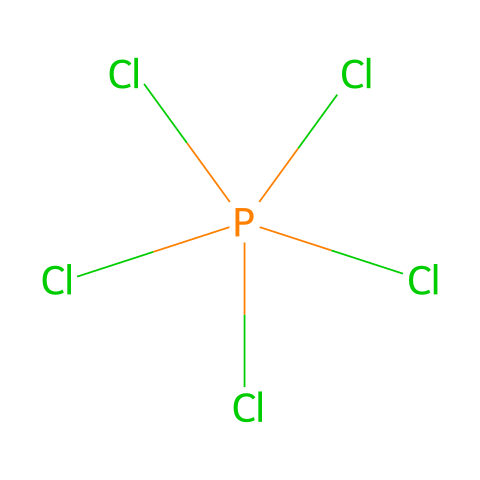What is the central atom in this compound? The SMILES representation indicates the presence of phosphorus as the central atom because it follows the brackets indicating the bonding with multiple chlorine atoms.
Answer: phosphorus How many chlorine atoms are bonded to the central atom? The representation shows five chlorine atoms (each denoted by "Cl") bonded to the phosphorus atom.
Answer: 5 What type of bonding is present in phosphorus pentachloride? The bonding involves single covalent bonds between the phosphorus and the chlorine atoms, as indicated by the structure.
Answer: covalent What is the formal charge on phosphorus in this compound? In phosphorus pentachloride, phosphorus typically has five valence electrons and forms five single bonds, leaving it with a formal charge of zero.
Answer: 0 Is phosphorus pentachloride an example of a hypervalent compound? Yes, phosphorus pentachloride is considered hypervalent because phosphorus is surrounded by more than four valence electrons from bonding with five chlorine atoms.
Answer: yes What geometry does phosphorus pentachloride exhibit? The arrangement of five chlorine atoms around phosphorus suggests a trigonal bipyramidal geometry, based on VSEPR theory.
Answer: trigonal bipyramidal 